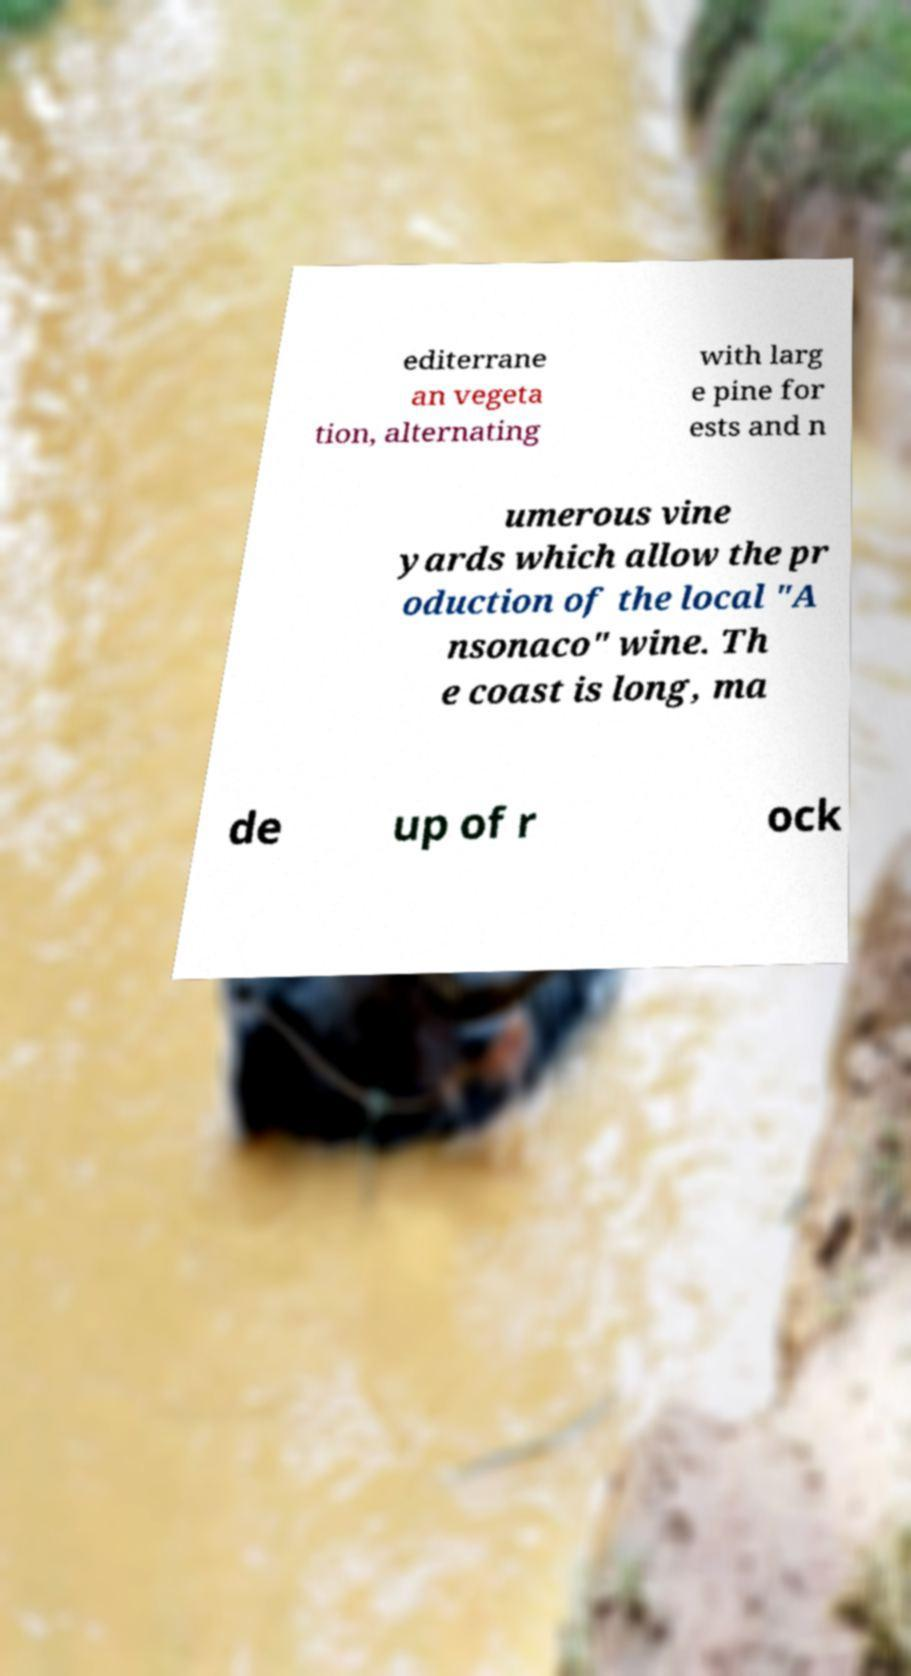I need the written content from this picture converted into text. Can you do that? editerrane an vegeta tion, alternating with larg e pine for ests and n umerous vine yards which allow the pr oduction of the local "A nsonaco" wine. Th e coast is long, ma de up of r ock 